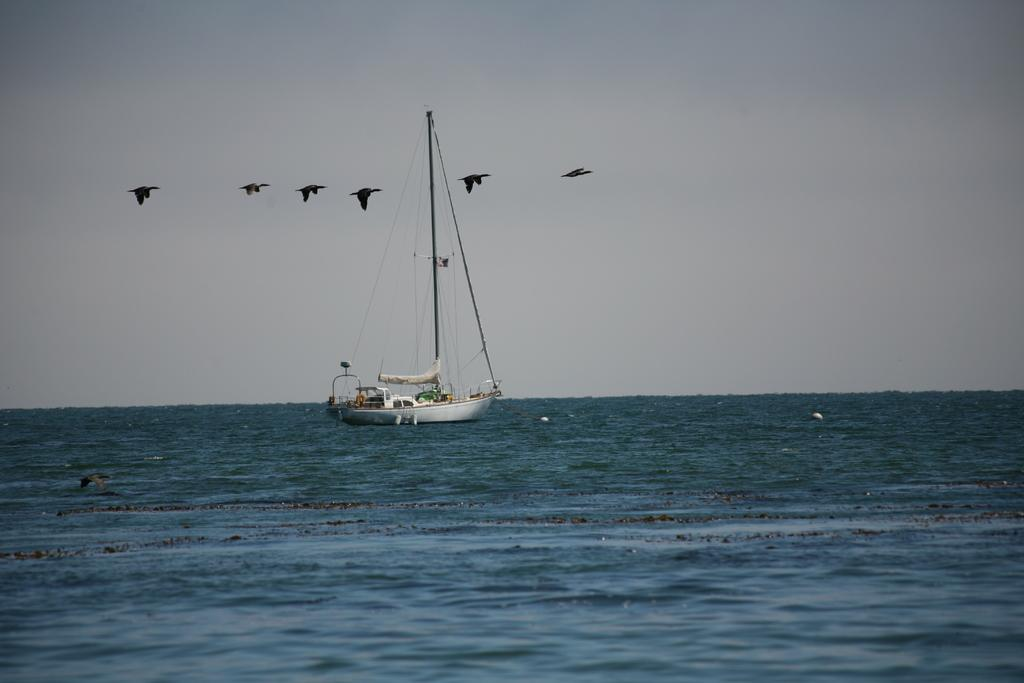What is the main subject of the image? The main subject of the image is a boat. What other living creatures can be seen in the image? There are birds visible in the image. What type of environment is depicted in the image? The image shows a water environment, as water is visible. What is visible at the top of the image? The sky is visible at the top of the image. What type of fuel is being used by the birds in the image? There is no indication in the image that the birds are using any fuel, as birds do not require fuel to fly. How many beds are visible in the image? There are no beds present in the image. 